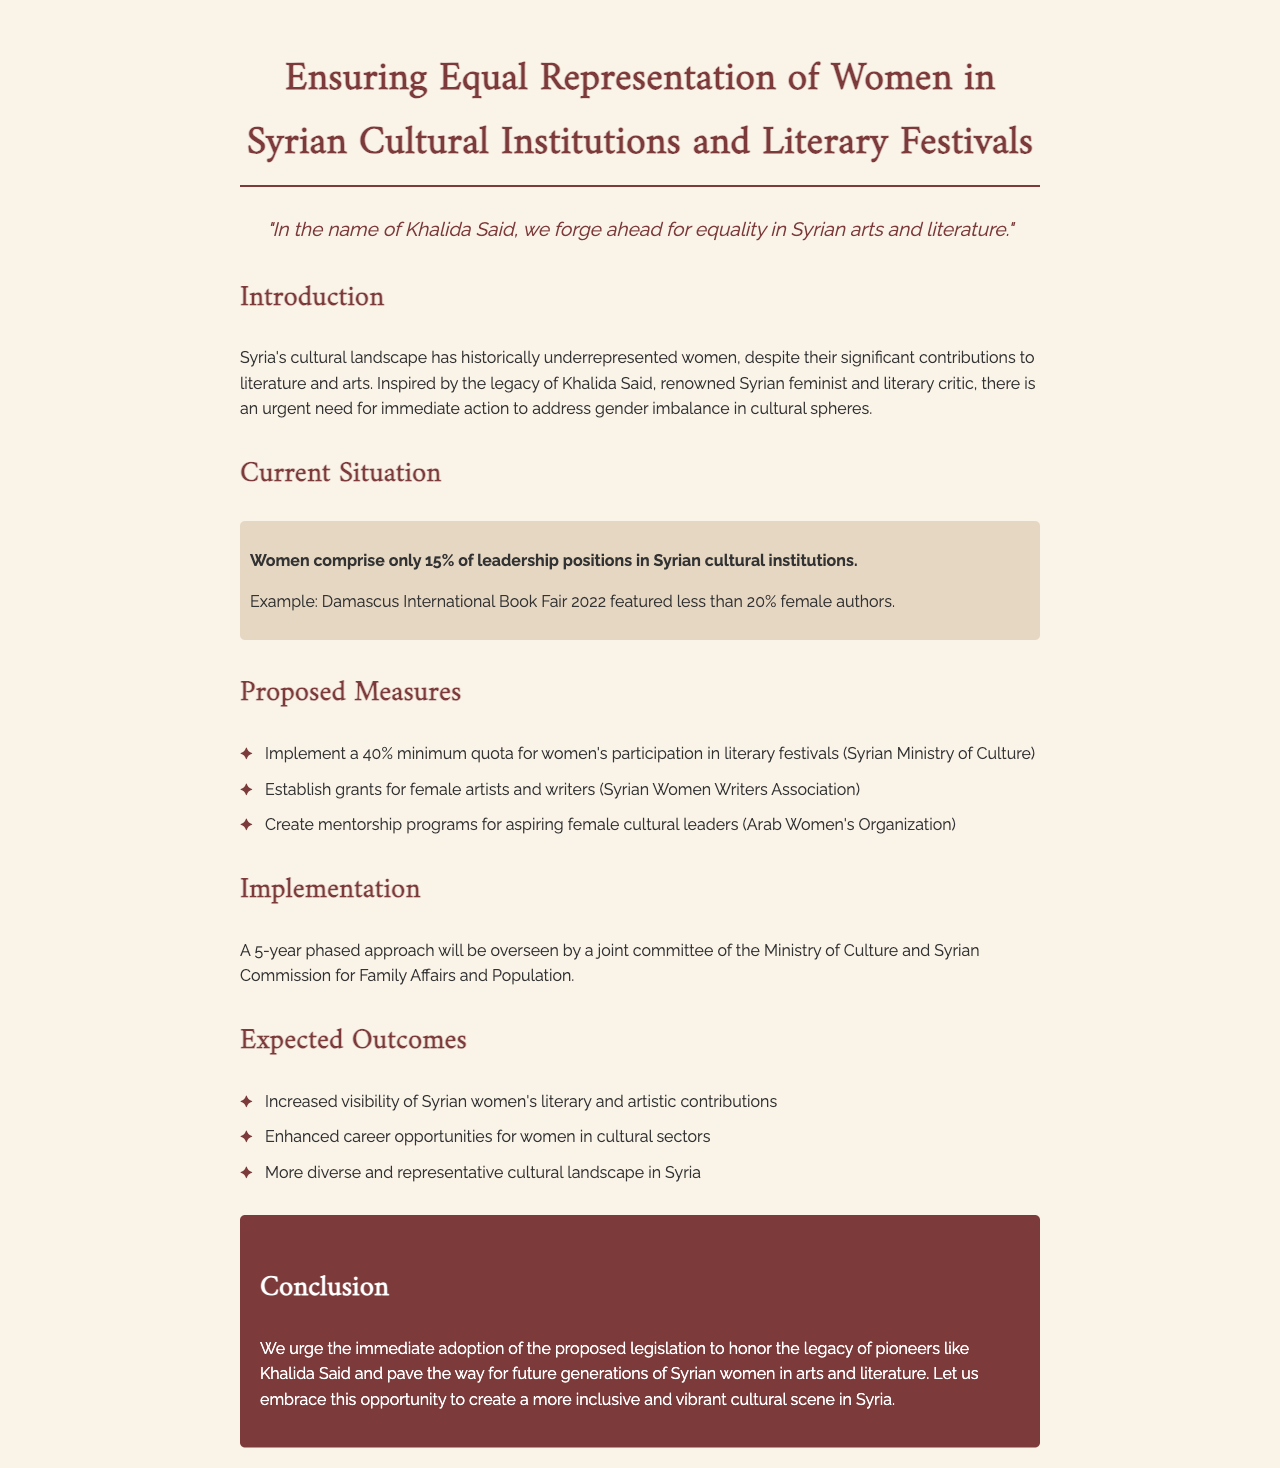What is the main focus of the proposed legislation? The document focuses on ensuring equal representation of women in Syrian cultural institutions and literary festivals.
Answer: Equal representation of women What percentage of leadership positions in Syrian cultural institutions are held by women? The document states that women comprise only 15% of leadership positions in Syrian cultural institutions.
Answer: 15% What is the minimum quota proposed for women's participation in literary festivals? The proposed minimum quota for women's participation in literary festivals is 40%.
Answer: 40% Who is inspired by the proposed measures mentioned in the document? The proposed measures are inspired by the legacy of Khalida Said.
Answer: Khalida Said What is one expected outcome of the proposed legislation? One expected outcome is increased visibility of Syrian women's literary and artistic contributions.
Answer: Increased visibility of contributions 